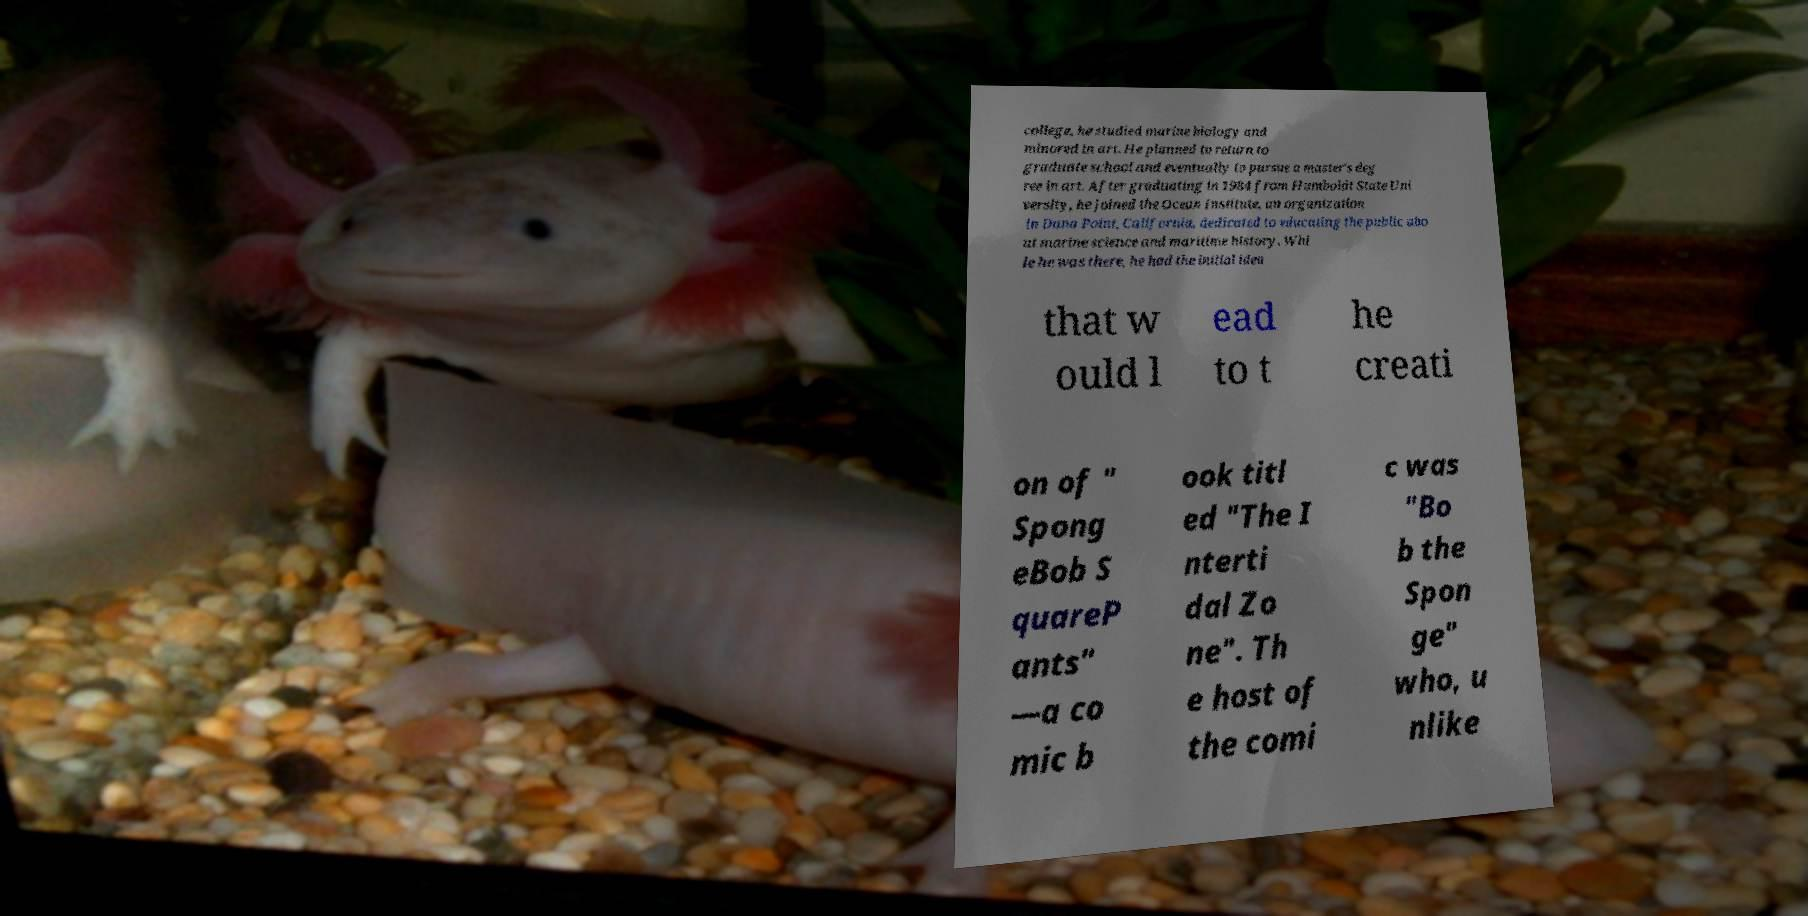What messages or text are displayed in this image? I need them in a readable, typed format. college, he studied marine biology and minored in art. He planned to return to graduate school and eventually to pursue a master's deg ree in art. After graduating in 1984 from Humboldt State Uni versity, he joined the Ocean Institute, an organization in Dana Point, California, dedicated to educating the public abo ut marine science and maritime history. Whi le he was there, he had the initial idea that w ould l ead to t he creati on of " Spong eBob S quareP ants" —a co mic b ook titl ed "The I nterti dal Zo ne". Th e host of the comi c was "Bo b the Spon ge" who, u nlike 